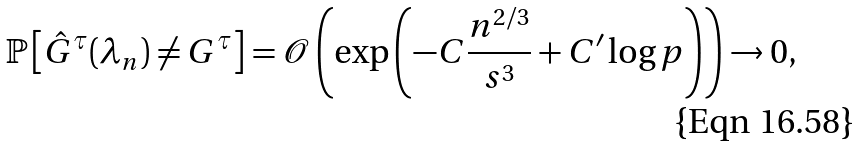Convert formula to latex. <formula><loc_0><loc_0><loc_500><loc_500>\mathbb { P } \left [ \hat { G } ^ { \tau } ( \lambda _ { n } ) \neq G ^ { \tau } \right ] = \mathcal { O } \left ( \exp \left ( - C \frac { n ^ { 2 / 3 } } { s ^ { 3 } } + C ^ { \prime } \log p \right ) \right ) \rightarrow 0 ,</formula> 